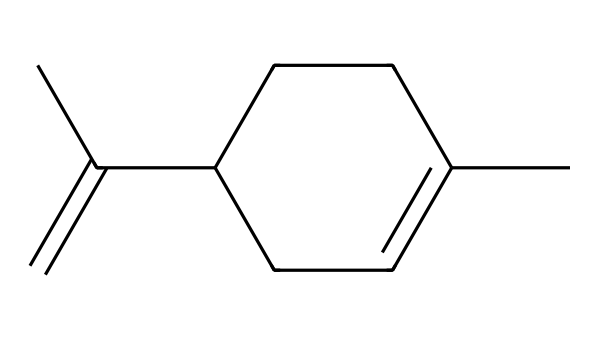What is the molecular formula of limonene? By observing the structure, we can count the number of carbon (C) and hydrogen (H) atoms. There are 10 carbon atoms and 16 hydrogen atoms in this chemical structure, which gives us the molecular formula C10H16.
Answer: C10H16 How many chiral centers are present in limonene? In the structure, we identify the carbon atoms to determine which are chiral centers. A chiral center has four different substituents; in limonene, there are no carbons with four distinct groups, so there are zero chiral centers.
Answer: 0 What is a major characteristic of limonene enantiomers? The enantiomers of limonene (D-limonene and L-limonene) are characterized by their optical activity, where they rotate plane-polarized light in opposite directions; D-limonene is dextrorotatory and L-limonene is levorotatory.
Answer: Optical activity Which physical property differs between the enantiomers? The boiling point is a key physical property that can differ between enantiomers due to their different interactions with chiral solvents or other compounds, despite having the same molecular formula.
Answer: Boiling point How does limonene's structure contribute to its fragrance? Limonene has a cyclic structure and non-polar characteristics that enhance its volatility, leading to the release of scent molecules more efficiently; the specific arrangement of its carbon skeleton allows it to produce a citrus smell often associated with fruits.
Answer: Citrus smell 